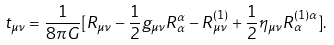<formula> <loc_0><loc_0><loc_500><loc_500>t _ { \mu \nu } = \frac { 1 } { 8 \pi G } [ R _ { \mu \nu } - \frac { 1 } { 2 } g _ { \mu \nu } R _ { \alpha } ^ { \alpha } - R _ { \mu \nu } ^ { ( 1 ) } + \frac { 1 } { 2 } \eta _ { \mu \nu } R _ { \alpha } ^ { ( 1 ) \alpha } ] .</formula> 